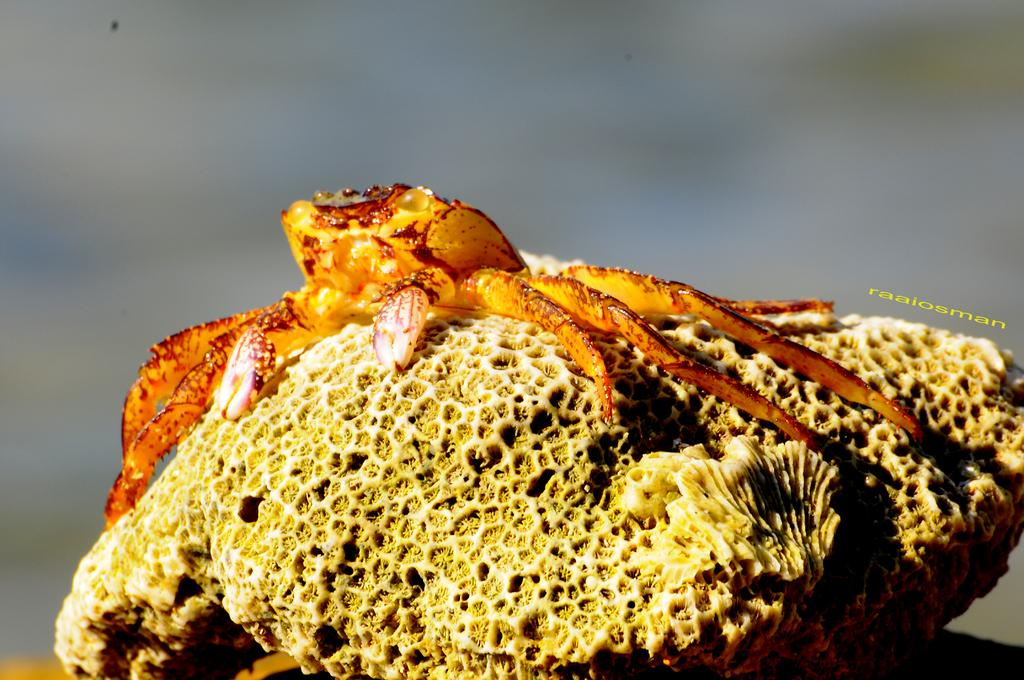What type of animal is in the image? There is a crab in the image. Can you describe the color of the crab? The crab has an orange and brown color combination. What is the crab resting on in the image? The crab is on a stone. How would you describe the background of the image? The background of the image is blurred. What type of potato is being held by the cow in the image? There is no cow or potato present in the image; it features a crab on a stone with a blurred background. 